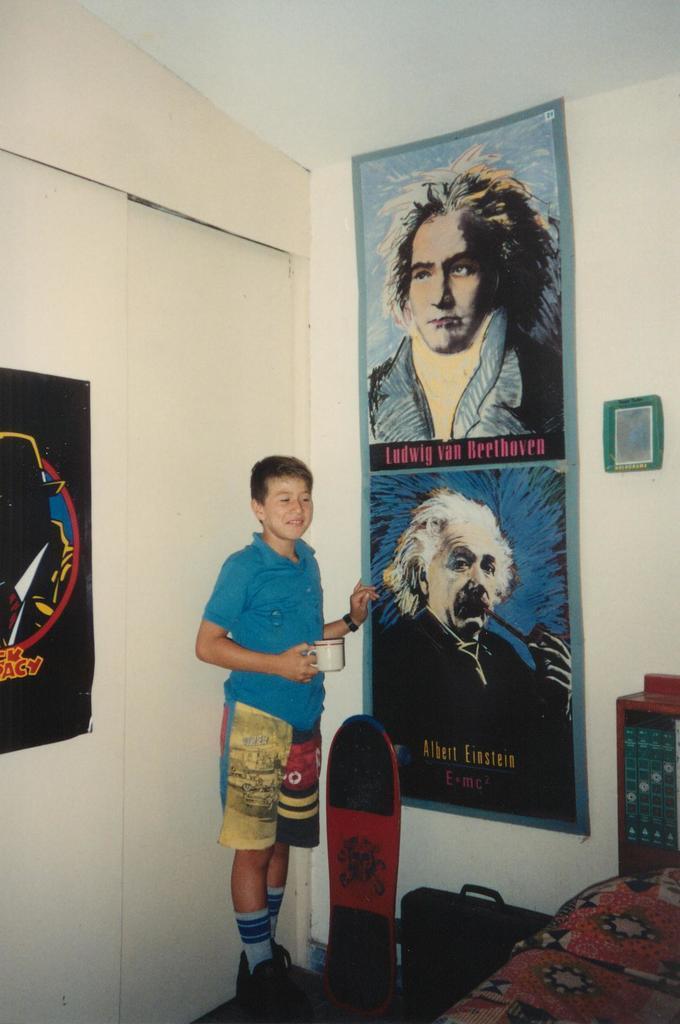Can you describe this image briefly? In the center of the image there is a boy standing holding a cup. There is a skateboard beside him. There is a wall on which there is a poster with depictions of persons and text. There is a door. To the right side of the image there is a bed. At the top of the image there is ceiling. To the left side of the image there is a poster on the wall. 